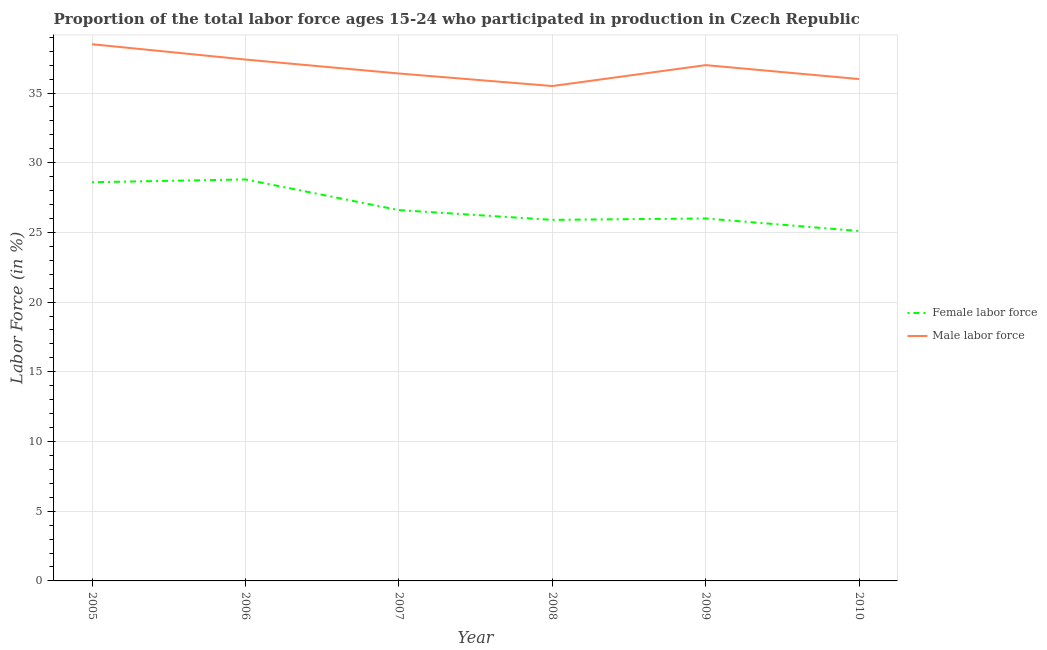Is the number of lines equal to the number of legend labels?
Offer a terse response. Yes. What is the percentage of female labor force in 2010?
Keep it short and to the point. 25.1. Across all years, what is the maximum percentage of female labor force?
Provide a succinct answer. 28.8. Across all years, what is the minimum percentage of female labor force?
Make the answer very short. 25.1. What is the total percentage of male labour force in the graph?
Ensure brevity in your answer.  220.8. What is the difference between the percentage of female labor force in 2005 and that in 2006?
Make the answer very short. -0.2. What is the difference between the percentage of female labor force in 2008 and the percentage of male labour force in 2007?
Your answer should be compact. -10.5. What is the average percentage of female labor force per year?
Your response must be concise. 26.83. In the year 2006, what is the difference between the percentage of male labour force and percentage of female labor force?
Offer a very short reply. 8.6. What is the ratio of the percentage of female labor force in 2005 to that in 2007?
Keep it short and to the point. 1.08. Is the percentage of male labour force in 2006 less than that in 2009?
Your answer should be compact. No. What is the difference between the highest and the second highest percentage of male labour force?
Make the answer very short. 1.1. What is the difference between the highest and the lowest percentage of female labor force?
Make the answer very short. 3.7. In how many years, is the percentage of female labor force greater than the average percentage of female labor force taken over all years?
Ensure brevity in your answer.  2. Is the percentage of male labour force strictly greater than the percentage of female labor force over the years?
Keep it short and to the point. Yes. Is the percentage of female labor force strictly less than the percentage of male labour force over the years?
Your response must be concise. Yes. How many years are there in the graph?
Make the answer very short. 6. What is the difference between two consecutive major ticks on the Y-axis?
Make the answer very short. 5. Are the values on the major ticks of Y-axis written in scientific E-notation?
Your answer should be very brief. No. Does the graph contain grids?
Your answer should be compact. Yes. How many legend labels are there?
Your response must be concise. 2. How are the legend labels stacked?
Your answer should be very brief. Vertical. What is the title of the graph?
Offer a very short reply. Proportion of the total labor force ages 15-24 who participated in production in Czech Republic. What is the label or title of the X-axis?
Your answer should be very brief. Year. What is the label or title of the Y-axis?
Offer a very short reply. Labor Force (in %). What is the Labor Force (in %) of Female labor force in 2005?
Provide a succinct answer. 28.6. What is the Labor Force (in %) of Male labor force in 2005?
Provide a short and direct response. 38.5. What is the Labor Force (in %) of Female labor force in 2006?
Your response must be concise. 28.8. What is the Labor Force (in %) in Male labor force in 2006?
Provide a succinct answer. 37.4. What is the Labor Force (in %) in Female labor force in 2007?
Your answer should be compact. 26.6. What is the Labor Force (in %) in Male labor force in 2007?
Offer a very short reply. 36.4. What is the Labor Force (in %) of Female labor force in 2008?
Offer a terse response. 25.9. What is the Labor Force (in %) of Male labor force in 2008?
Provide a short and direct response. 35.5. What is the Labor Force (in %) of Female labor force in 2010?
Provide a short and direct response. 25.1. Across all years, what is the maximum Labor Force (in %) of Female labor force?
Offer a very short reply. 28.8. Across all years, what is the maximum Labor Force (in %) of Male labor force?
Your response must be concise. 38.5. Across all years, what is the minimum Labor Force (in %) in Female labor force?
Offer a very short reply. 25.1. Across all years, what is the minimum Labor Force (in %) in Male labor force?
Provide a succinct answer. 35.5. What is the total Labor Force (in %) in Female labor force in the graph?
Your answer should be very brief. 161. What is the total Labor Force (in %) in Male labor force in the graph?
Provide a succinct answer. 220.8. What is the difference between the Labor Force (in %) in Male labor force in 2005 and that in 2006?
Provide a short and direct response. 1.1. What is the difference between the Labor Force (in %) of Female labor force in 2005 and that in 2008?
Your answer should be compact. 2.7. What is the difference between the Labor Force (in %) of Male labor force in 2005 and that in 2008?
Make the answer very short. 3. What is the difference between the Labor Force (in %) in Male labor force in 2005 and that in 2009?
Offer a very short reply. 1.5. What is the difference between the Labor Force (in %) of Female labor force in 2005 and that in 2010?
Provide a short and direct response. 3.5. What is the difference between the Labor Force (in %) in Female labor force in 2006 and that in 2009?
Keep it short and to the point. 2.8. What is the difference between the Labor Force (in %) in Female labor force in 2006 and that in 2010?
Ensure brevity in your answer.  3.7. What is the difference between the Labor Force (in %) of Male labor force in 2007 and that in 2008?
Your answer should be compact. 0.9. What is the difference between the Labor Force (in %) in Female labor force in 2007 and that in 2009?
Ensure brevity in your answer.  0.6. What is the difference between the Labor Force (in %) in Male labor force in 2008 and that in 2009?
Provide a short and direct response. -1.5. What is the difference between the Labor Force (in %) of Female labor force in 2008 and that in 2010?
Your response must be concise. 0.8. What is the difference between the Labor Force (in %) in Male labor force in 2009 and that in 2010?
Make the answer very short. 1. What is the difference between the Labor Force (in %) in Female labor force in 2005 and the Labor Force (in %) in Male labor force in 2007?
Offer a very short reply. -7.8. What is the difference between the Labor Force (in %) of Female labor force in 2005 and the Labor Force (in %) of Male labor force in 2009?
Ensure brevity in your answer.  -8.4. What is the difference between the Labor Force (in %) of Female labor force in 2005 and the Labor Force (in %) of Male labor force in 2010?
Give a very brief answer. -7.4. What is the difference between the Labor Force (in %) of Female labor force in 2006 and the Labor Force (in %) of Male labor force in 2007?
Give a very brief answer. -7.6. What is the difference between the Labor Force (in %) in Female labor force in 2006 and the Labor Force (in %) in Male labor force in 2008?
Offer a terse response. -6.7. What is the difference between the Labor Force (in %) of Female labor force in 2006 and the Labor Force (in %) of Male labor force in 2009?
Your answer should be very brief. -8.2. What is the difference between the Labor Force (in %) of Female labor force in 2007 and the Labor Force (in %) of Male labor force in 2008?
Your response must be concise. -8.9. What is the difference between the Labor Force (in %) of Female labor force in 2007 and the Labor Force (in %) of Male labor force in 2009?
Give a very brief answer. -10.4. What is the difference between the Labor Force (in %) of Female labor force in 2007 and the Labor Force (in %) of Male labor force in 2010?
Provide a succinct answer. -9.4. What is the difference between the Labor Force (in %) in Female labor force in 2008 and the Labor Force (in %) in Male labor force in 2009?
Offer a very short reply. -11.1. What is the difference between the Labor Force (in %) of Female labor force in 2008 and the Labor Force (in %) of Male labor force in 2010?
Your response must be concise. -10.1. What is the difference between the Labor Force (in %) of Female labor force in 2009 and the Labor Force (in %) of Male labor force in 2010?
Your response must be concise. -10. What is the average Labor Force (in %) in Female labor force per year?
Offer a very short reply. 26.83. What is the average Labor Force (in %) in Male labor force per year?
Your response must be concise. 36.8. In the year 2005, what is the difference between the Labor Force (in %) of Female labor force and Labor Force (in %) of Male labor force?
Offer a very short reply. -9.9. In the year 2009, what is the difference between the Labor Force (in %) in Female labor force and Labor Force (in %) in Male labor force?
Keep it short and to the point. -11. What is the ratio of the Labor Force (in %) in Male labor force in 2005 to that in 2006?
Make the answer very short. 1.03. What is the ratio of the Labor Force (in %) of Female labor force in 2005 to that in 2007?
Provide a short and direct response. 1.08. What is the ratio of the Labor Force (in %) of Male labor force in 2005 to that in 2007?
Offer a very short reply. 1.06. What is the ratio of the Labor Force (in %) in Female labor force in 2005 to that in 2008?
Keep it short and to the point. 1.1. What is the ratio of the Labor Force (in %) of Male labor force in 2005 to that in 2008?
Your answer should be very brief. 1.08. What is the ratio of the Labor Force (in %) of Female labor force in 2005 to that in 2009?
Ensure brevity in your answer.  1.1. What is the ratio of the Labor Force (in %) in Male labor force in 2005 to that in 2009?
Your answer should be compact. 1.04. What is the ratio of the Labor Force (in %) in Female labor force in 2005 to that in 2010?
Make the answer very short. 1.14. What is the ratio of the Labor Force (in %) of Male labor force in 2005 to that in 2010?
Your answer should be very brief. 1.07. What is the ratio of the Labor Force (in %) of Female labor force in 2006 to that in 2007?
Your answer should be compact. 1.08. What is the ratio of the Labor Force (in %) in Male labor force in 2006 to that in 2007?
Give a very brief answer. 1.03. What is the ratio of the Labor Force (in %) in Female labor force in 2006 to that in 2008?
Offer a terse response. 1.11. What is the ratio of the Labor Force (in %) of Male labor force in 2006 to that in 2008?
Your answer should be very brief. 1.05. What is the ratio of the Labor Force (in %) in Female labor force in 2006 to that in 2009?
Provide a short and direct response. 1.11. What is the ratio of the Labor Force (in %) in Male labor force in 2006 to that in 2009?
Your answer should be compact. 1.01. What is the ratio of the Labor Force (in %) in Female labor force in 2006 to that in 2010?
Your answer should be very brief. 1.15. What is the ratio of the Labor Force (in %) in Male labor force in 2006 to that in 2010?
Ensure brevity in your answer.  1.04. What is the ratio of the Labor Force (in %) of Male labor force in 2007 to that in 2008?
Your answer should be compact. 1.03. What is the ratio of the Labor Force (in %) in Female labor force in 2007 to that in 2009?
Provide a succinct answer. 1.02. What is the ratio of the Labor Force (in %) of Male labor force in 2007 to that in 2009?
Provide a succinct answer. 0.98. What is the ratio of the Labor Force (in %) of Female labor force in 2007 to that in 2010?
Ensure brevity in your answer.  1.06. What is the ratio of the Labor Force (in %) of Male labor force in 2007 to that in 2010?
Your answer should be compact. 1.01. What is the ratio of the Labor Force (in %) in Male labor force in 2008 to that in 2009?
Ensure brevity in your answer.  0.96. What is the ratio of the Labor Force (in %) in Female labor force in 2008 to that in 2010?
Give a very brief answer. 1.03. What is the ratio of the Labor Force (in %) in Male labor force in 2008 to that in 2010?
Provide a succinct answer. 0.99. What is the ratio of the Labor Force (in %) of Female labor force in 2009 to that in 2010?
Your response must be concise. 1.04. What is the ratio of the Labor Force (in %) in Male labor force in 2009 to that in 2010?
Your response must be concise. 1.03. 